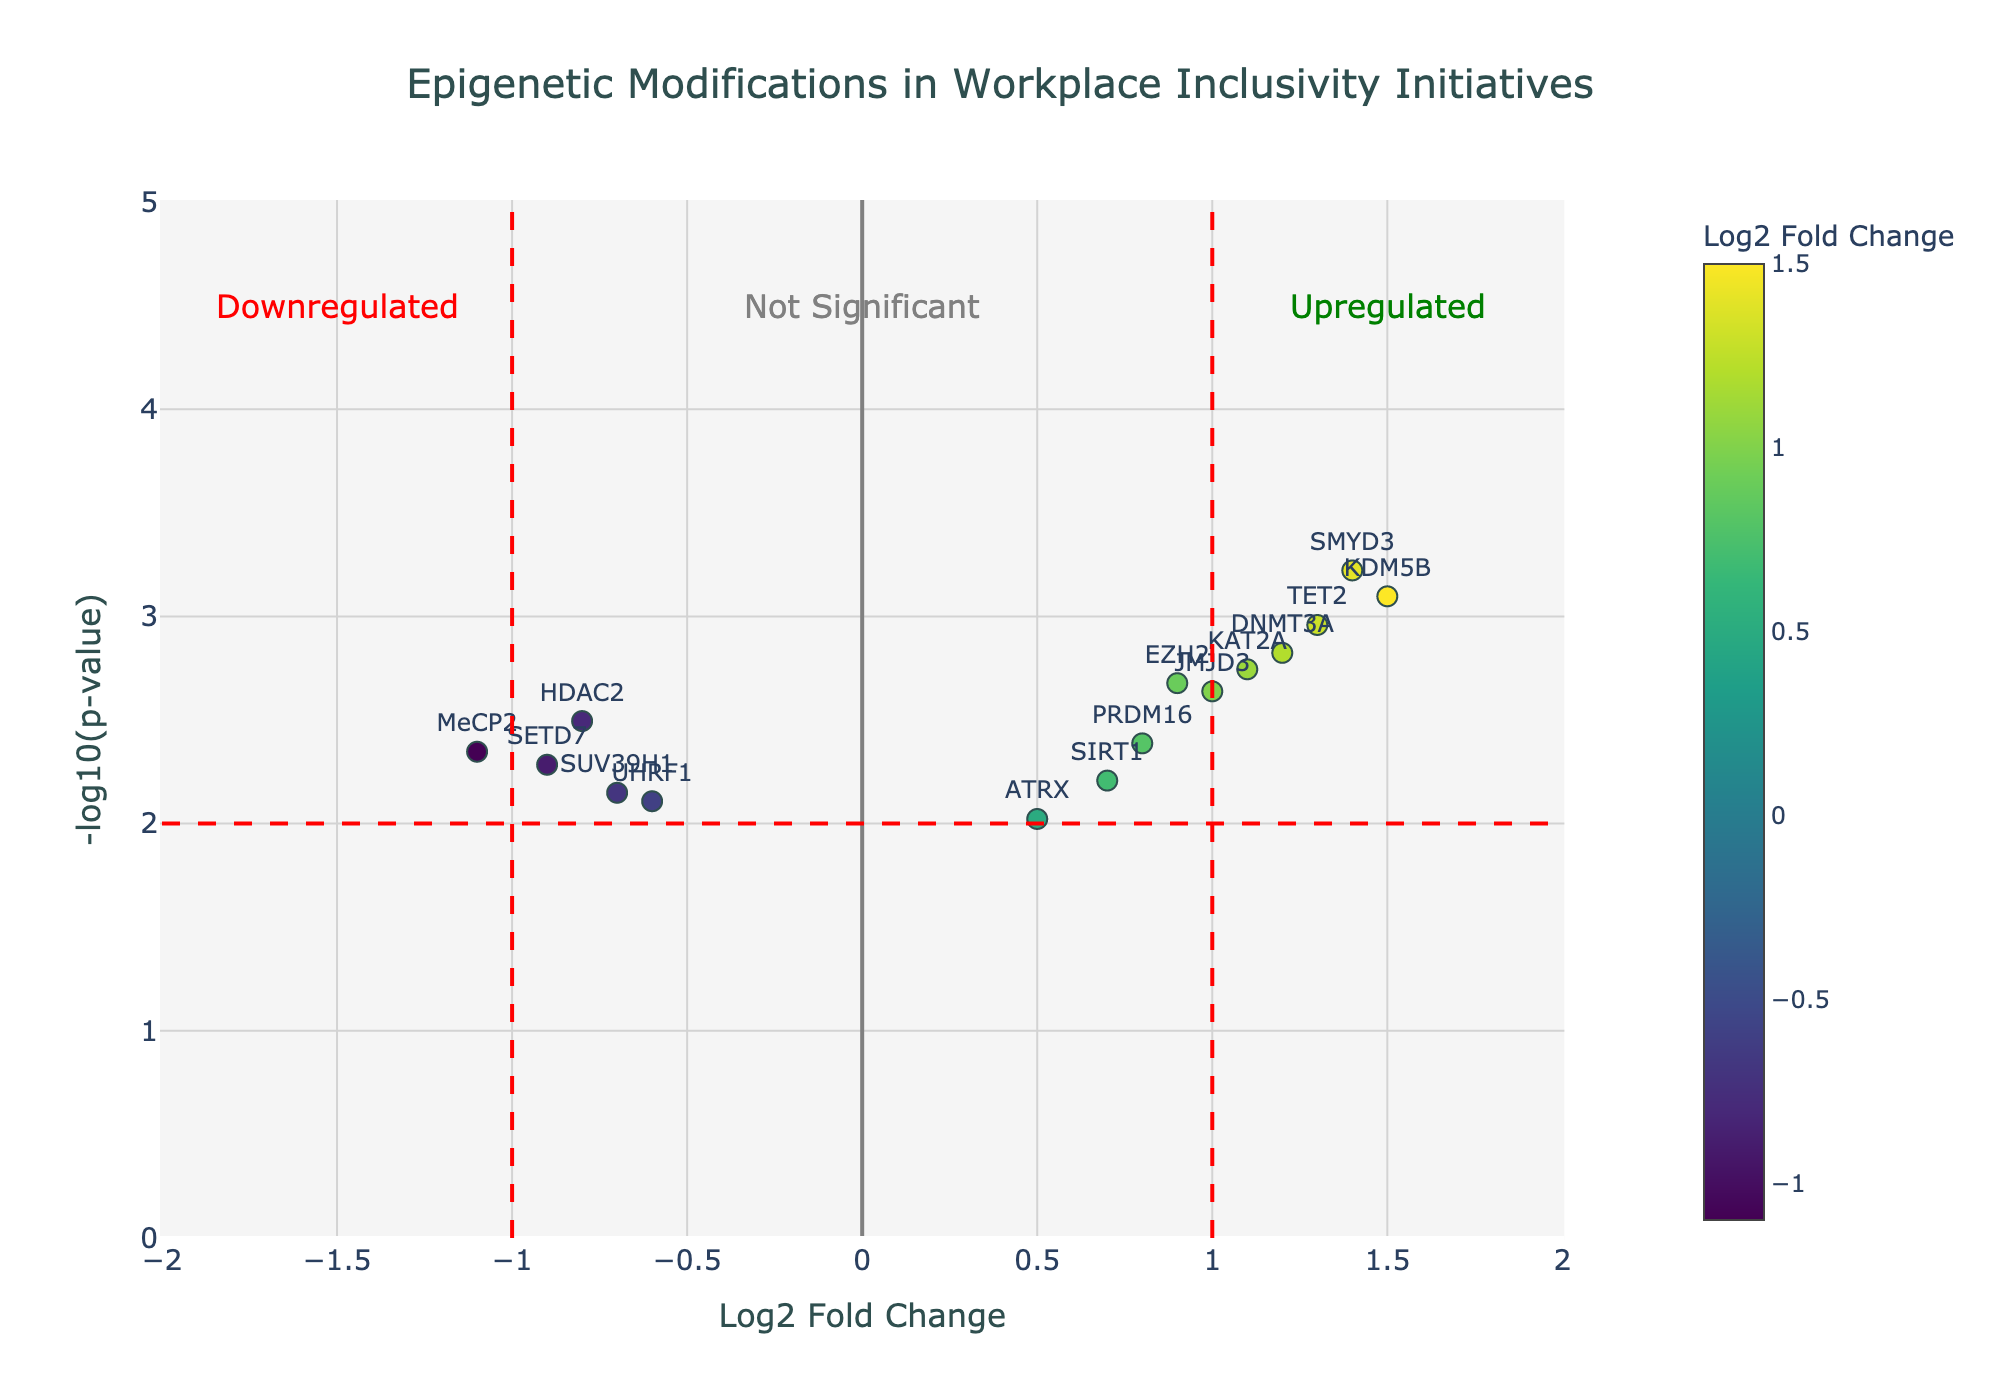Which gene has the highest -log10(p-value)? By reading off the y-axis, we identify that SMYD3 has the highest value for -log10(p-value).
Answer: SMYD3 What is the log2 fold change of MeCP2? Locate MeCP2 on the plot and read the corresponding x-axis value for log2 fold change.
Answer: -1.1 Which gene is closest to the threshold line for upregulation? The vertical threshold for upregulation is at log2 fold change of +1. The gene closest to this value is KAT2A.
Answer: KAT2A How many genes are downregulated according to the red vertical threshold line? Count the number of genes on the left side of the left red vertical line at x=-1. There are 3 genes: HDAC2, MeCP2, and SETD7.
Answer: 3 What is the log2 fold change of the gene with the smallest p-value? The smallest p-value results in the highest -log10(p-value). From the plot, SMYD3 has the smallest p-value, and its log2 fold change is 1.4.
Answer: 1.4 Compare the p-values of DNMT3A and EZH2. Which one is smaller? From the graph, DNMT3A has a position higher on the y-axis (-log10(p-value)), indicating a smaller p-value than EZH2.
Answer: DNMT3A What is the range of log2 fold change values displayed? The range of log2 fold change values is from the smallest to the largest x-axis value. The lowest value is -1.1 (MeCP2), and the highest is 1.5 (KDM5B).
Answer: -1.1 to 1.5 Which gene has the second highest -log10(p-value)? By checking the y-axis values, KDM5B has the second highest -log10(p-value) after SMYD3.
Answer: KDM5B Determine the gene with the highest log2 fold change value. By locating the gene farthest to the right along the x-axis, we find that KDM5B has the highest log2 fold change.
Answer: KDM5B How many genes are not significantly different in both directions (i.e., between log2 fold change of -1 and +1)? Count the number of genes within the region between the two red vertical lines at x=-1 and x=1. There are 8 genes within this range.
Answer: 8 